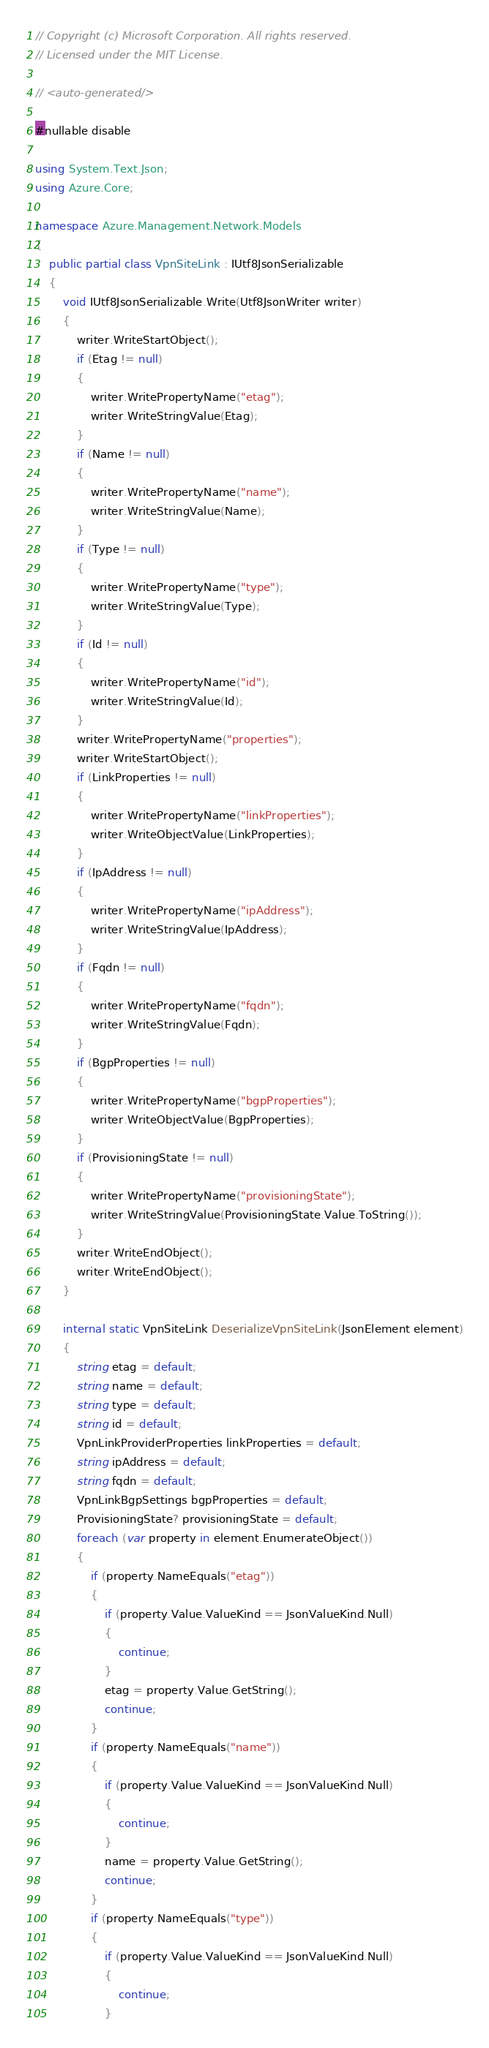<code> <loc_0><loc_0><loc_500><loc_500><_C#_>// Copyright (c) Microsoft Corporation. All rights reserved.
// Licensed under the MIT License.

// <auto-generated/>

#nullable disable

using System.Text.Json;
using Azure.Core;

namespace Azure.Management.Network.Models
{
    public partial class VpnSiteLink : IUtf8JsonSerializable
    {
        void IUtf8JsonSerializable.Write(Utf8JsonWriter writer)
        {
            writer.WriteStartObject();
            if (Etag != null)
            {
                writer.WritePropertyName("etag");
                writer.WriteStringValue(Etag);
            }
            if (Name != null)
            {
                writer.WritePropertyName("name");
                writer.WriteStringValue(Name);
            }
            if (Type != null)
            {
                writer.WritePropertyName("type");
                writer.WriteStringValue(Type);
            }
            if (Id != null)
            {
                writer.WritePropertyName("id");
                writer.WriteStringValue(Id);
            }
            writer.WritePropertyName("properties");
            writer.WriteStartObject();
            if (LinkProperties != null)
            {
                writer.WritePropertyName("linkProperties");
                writer.WriteObjectValue(LinkProperties);
            }
            if (IpAddress != null)
            {
                writer.WritePropertyName("ipAddress");
                writer.WriteStringValue(IpAddress);
            }
            if (Fqdn != null)
            {
                writer.WritePropertyName("fqdn");
                writer.WriteStringValue(Fqdn);
            }
            if (BgpProperties != null)
            {
                writer.WritePropertyName("bgpProperties");
                writer.WriteObjectValue(BgpProperties);
            }
            if (ProvisioningState != null)
            {
                writer.WritePropertyName("provisioningState");
                writer.WriteStringValue(ProvisioningState.Value.ToString());
            }
            writer.WriteEndObject();
            writer.WriteEndObject();
        }

        internal static VpnSiteLink DeserializeVpnSiteLink(JsonElement element)
        {
            string etag = default;
            string name = default;
            string type = default;
            string id = default;
            VpnLinkProviderProperties linkProperties = default;
            string ipAddress = default;
            string fqdn = default;
            VpnLinkBgpSettings bgpProperties = default;
            ProvisioningState? provisioningState = default;
            foreach (var property in element.EnumerateObject())
            {
                if (property.NameEquals("etag"))
                {
                    if (property.Value.ValueKind == JsonValueKind.Null)
                    {
                        continue;
                    }
                    etag = property.Value.GetString();
                    continue;
                }
                if (property.NameEquals("name"))
                {
                    if (property.Value.ValueKind == JsonValueKind.Null)
                    {
                        continue;
                    }
                    name = property.Value.GetString();
                    continue;
                }
                if (property.NameEquals("type"))
                {
                    if (property.Value.ValueKind == JsonValueKind.Null)
                    {
                        continue;
                    }</code> 